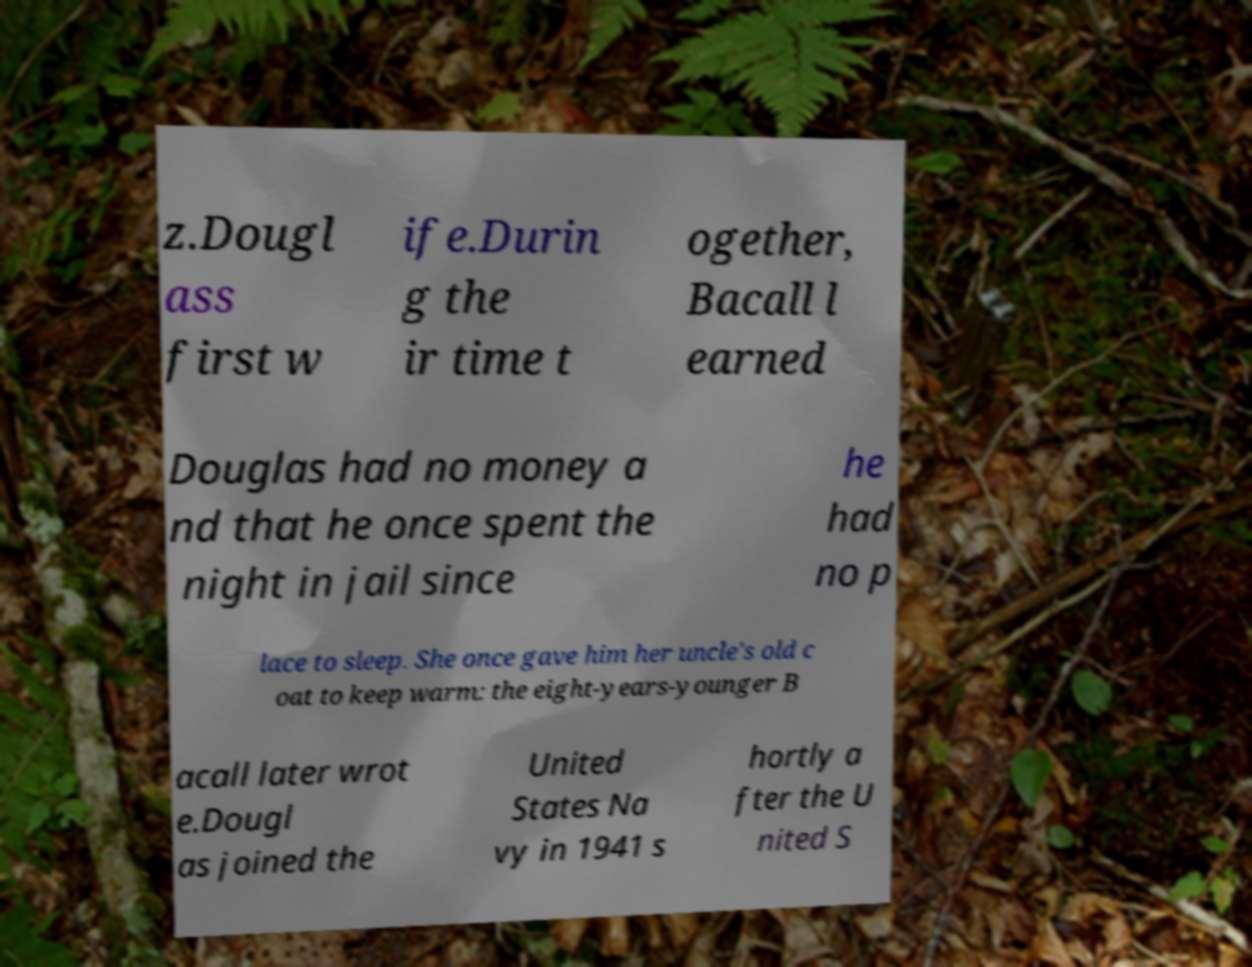Could you assist in decoding the text presented in this image and type it out clearly? z.Dougl ass first w ife.Durin g the ir time t ogether, Bacall l earned Douglas had no money a nd that he once spent the night in jail since he had no p lace to sleep. She once gave him her uncle's old c oat to keep warm: the eight-years-younger B acall later wrot e.Dougl as joined the United States Na vy in 1941 s hortly a fter the U nited S 